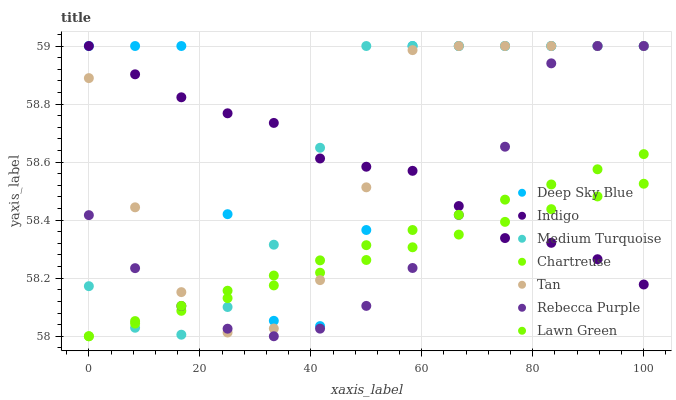Does Chartreuse have the minimum area under the curve?
Answer yes or no. Yes. Does Deep Sky Blue have the maximum area under the curve?
Answer yes or no. Yes. Does Indigo have the minimum area under the curve?
Answer yes or no. No. Does Indigo have the maximum area under the curve?
Answer yes or no. No. Is Chartreuse the smoothest?
Answer yes or no. Yes. Is Deep Sky Blue the roughest?
Answer yes or no. Yes. Is Indigo the smoothest?
Answer yes or no. No. Is Indigo the roughest?
Answer yes or no. No. Does Lawn Green have the lowest value?
Answer yes or no. Yes. Does Deep Sky Blue have the lowest value?
Answer yes or no. No. Does Tan have the highest value?
Answer yes or no. Yes. Does Chartreuse have the highest value?
Answer yes or no. No. Does Medium Turquoise intersect Tan?
Answer yes or no. Yes. Is Medium Turquoise less than Tan?
Answer yes or no. No. Is Medium Turquoise greater than Tan?
Answer yes or no. No. 